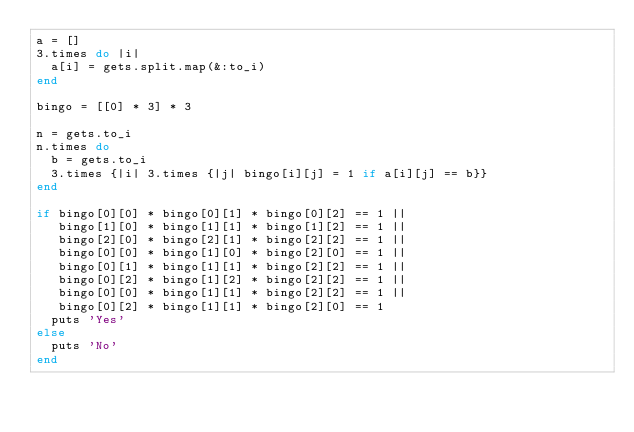Convert code to text. <code><loc_0><loc_0><loc_500><loc_500><_Ruby_>a = []
3.times do |i|
  a[i] = gets.split.map(&:to_i)
end

bingo = [[0] * 3] * 3

n = gets.to_i
n.times do
  b = gets.to_i
  3.times {|i| 3.times {|j| bingo[i][j] = 1 if a[i][j] == b}}
end

if bingo[0][0] * bingo[0][1] * bingo[0][2] == 1 ||
   bingo[1][0] * bingo[1][1] * bingo[1][2] == 1 ||
   bingo[2][0] * bingo[2][1] * bingo[2][2] == 1 ||
   bingo[0][0] * bingo[1][0] * bingo[2][0] == 1 ||
   bingo[0][1] * bingo[1][1] * bingo[2][2] == 1 ||
   bingo[0][2] * bingo[1][2] * bingo[2][2] == 1 ||
   bingo[0][0] * bingo[1][1] * bingo[2][2] == 1 ||
   bingo[0][2] * bingo[1][1] * bingo[2][0] == 1
  puts 'Yes'
else
  puts 'No'
end</code> 